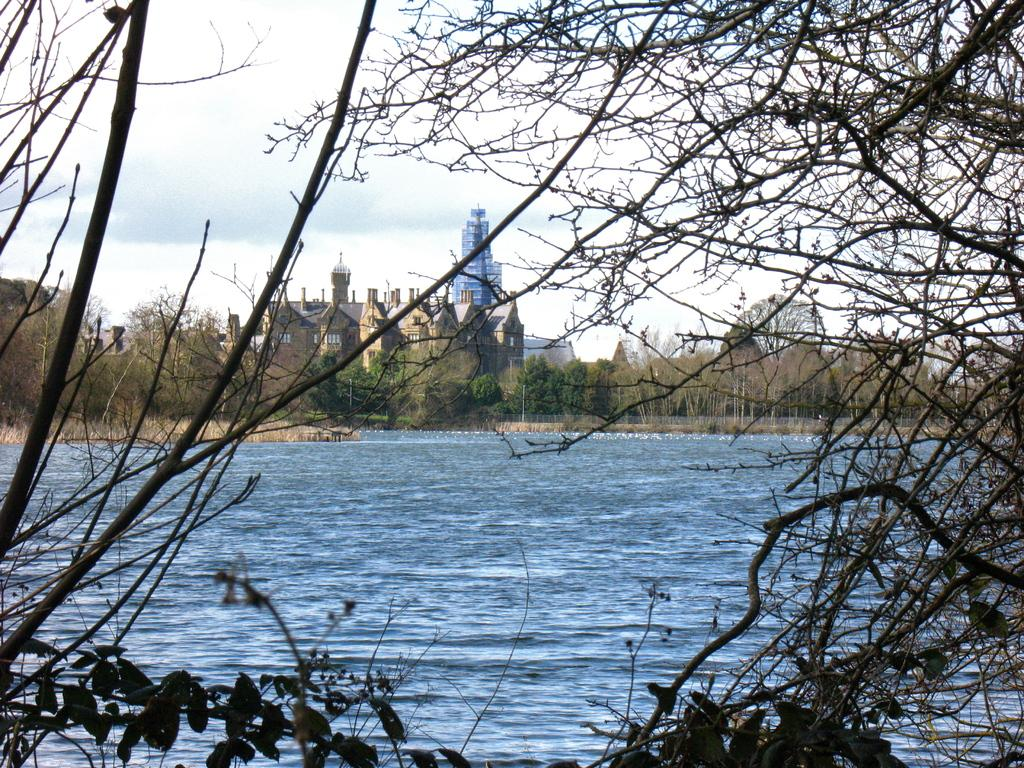What is at the bottom of the image? There is water at the bottom of the image. What type of vegetation can be seen in the image? There are trees in the image. What structures are located in the middle of the image? There are buildings in the middle of the image. What is visible at the top of the image? The sky is visible at the top of the image. What is the weather like in the image? The sky is cloudy in the image. What type of insurance is being sold by the trees in the image? There is no indication of insurance being sold in the image; the trees are simply part of the natural landscape. What type of business is being conducted in the buildings in the image? The image does not provide any information about the businesses being conducted in the buildings. 